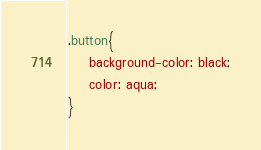<code> <loc_0><loc_0><loc_500><loc_500><_CSS_>.button{
    background-color: black;
    color: aqua;
}</code> 